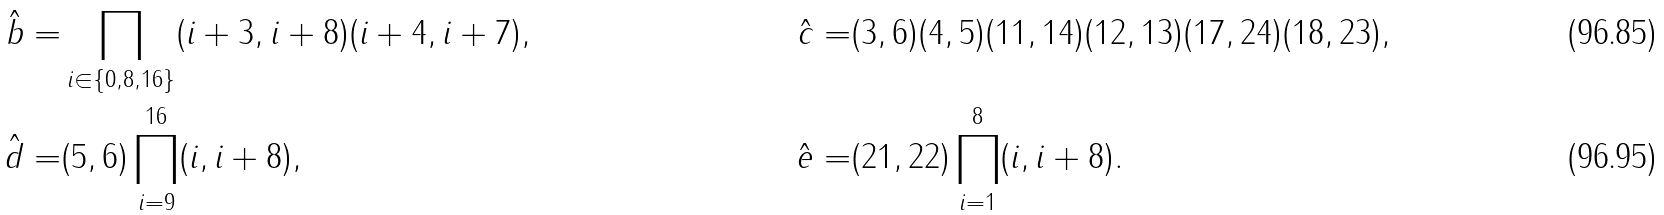<formula> <loc_0><loc_0><loc_500><loc_500>\hat { b } = & \prod _ { i \in \{ 0 , 8 , 1 6 \} } ( i + 3 , i + 8 ) ( i + 4 , i + 7 ) , & \hat { c } = & ( 3 , 6 ) ( 4 , 5 ) ( 1 1 , 1 4 ) ( 1 2 , 1 3 ) ( 1 7 , 2 4 ) ( 1 8 , 2 3 ) , \\ \hat { d } = & ( 5 , 6 ) \prod _ { i = 9 } ^ { 1 6 } ( i , i + 8 ) , & \hat { e } = & ( 2 1 , 2 2 ) \prod _ { i = 1 } ^ { 8 } ( i , i + 8 ) .</formula> 